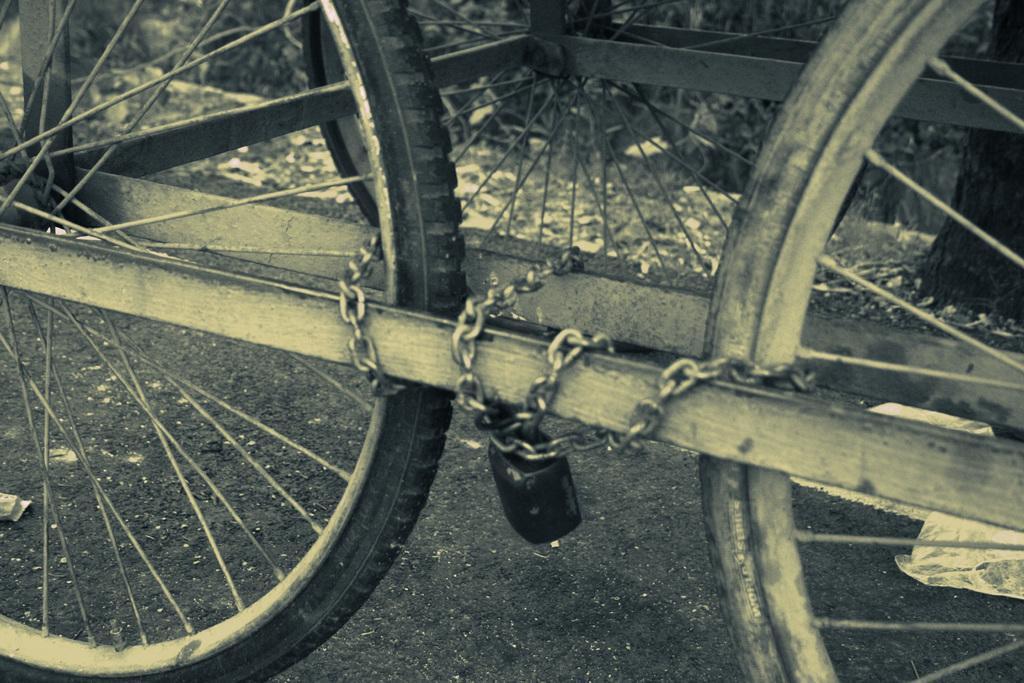How would you summarize this image in a sentence or two? In this picture I can see there are three wheels and they are tied with a chain and it is locked. There are some plastic covers on the floor. 